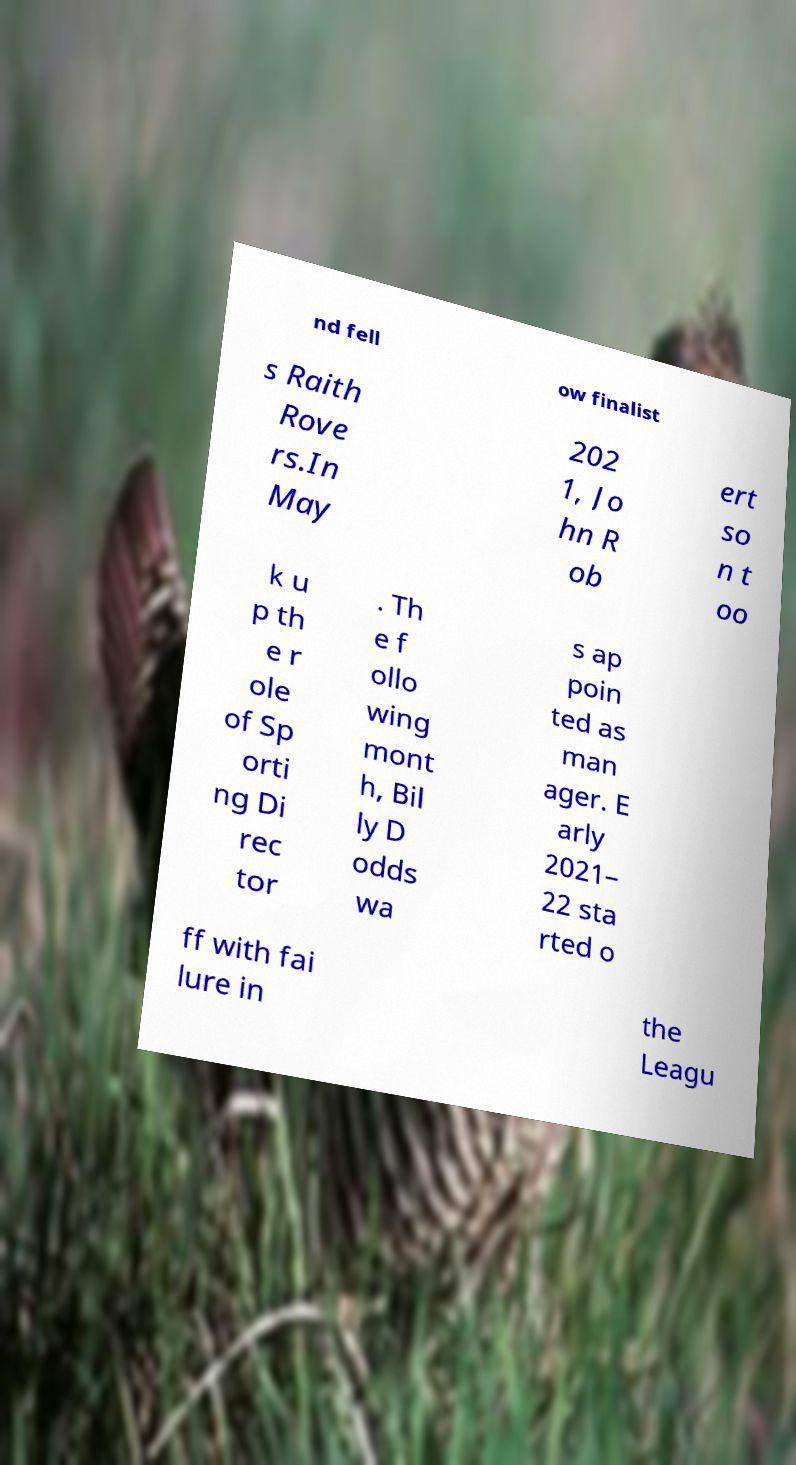Can you accurately transcribe the text from the provided image for me? nd fell ow finalist s Raith Rove rs.In May 202 1, Jo hn R ob ert so n t oo k u p th e r ole of Sp orti ng Di rec tor . Th e f ollo wing mont h, Bil ly D odds wa s ap poin ted as man ager. E arly 2021– 22 sta rted o ff with fai lure in the Leagu 